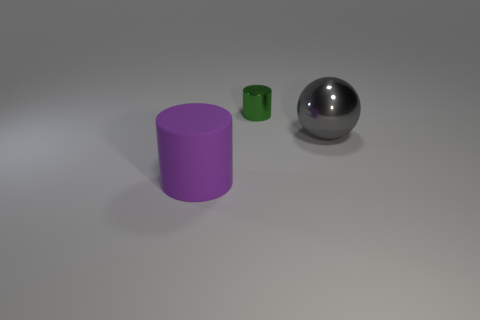Are there fewer tiny shiny cylinders that are on the left side of the small object than large balls?
Your response must be concise. Yes. The thing that is in front of the big thing to the right of the cylinder that is behind the matte cylinder is what shape?
Offer a terse response. Cylinder. Does the small green thing have the same shape as the large purple object?
Your answer should be compact. Yes. What number of other things are there of the same shape as the tiny green metal thing?
Your answer should be compact. 1. There is a metallic sphere that is the same size as the purple rubber thing; what color is it?
Your answer should be compact. Gray. Are there the same number of small green metal cylinders in front of the purple thing and purple matte cubes?
Offer a very short reply. Yes. There is a object that is on the left side of the big gray ball and to the right of the purple rubber cylinder; what shape is it?
Provide a short and direct response. Cylinder. Do the green object and the gray metal object have the same size?
Give a very brief answer. No. Is there a tiny green cylinder made of the same material as the big purple cylinder?
Make the answer very short. No. How many big things are both left of the tiny green shiny cylinder and behind the large matte object?
Make the answer very short. 0. 